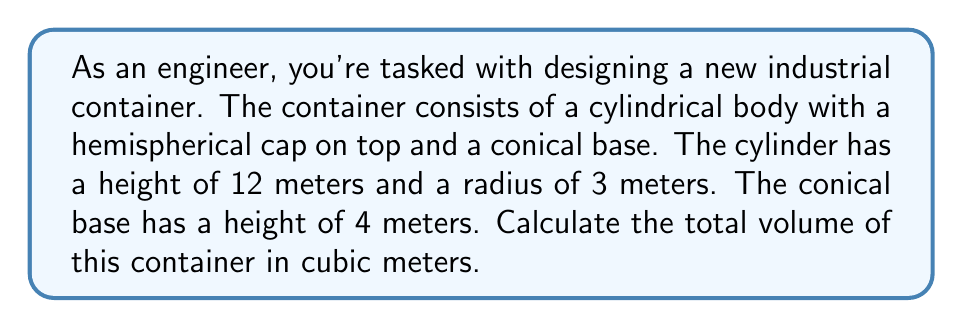Show me your answer to this math problem. Let's break this down step-by-step:

1. Calculate the volume of the cylindrical body:
   $$V_{cylinder} = \pi r^2 h$$
   $$V_{cylinder} = \pi \cdot 3^2 \cdot 12 = 108\pi \text{ m}^3$$

2. Calculate the volume of the hemispherical cap:
   $$V_{hemisphere} = \frac{2}{3}\pi r^3$$
   $$V_{hemisphere} = \frac{2}{3}\pi \cdot 3^3 = 18\pi \text{ m}^3$$

3. Calculate the volume of the conical base:
   $$V_{cone} = \frac{1}{3}\pi r^2 h$$
   $$V_{cone} = \frac{1}{3}\pi \cdot 3^2 \cdot 4 = 12\pi \text{ m}^3$$

4. Sum up all the volumes:
   $$V_{total} = V_{cylinder} + V_{hemisphere} + V_{cone}$$
   $$V_{total} = 108\pi + 18\pi + 12\pi = 138\pi \text{ m}^3$$

5. Simplify the final answer:
   $$V_{total} = 138\pi \approx 433.54 \text{ m}^3$$

[asy]
import three;

size(200);
currentprojection=perspective(6,3,2);

// Cylinder
draw(surface(cylinder((0,0,0),3,12)),lightgrey);

// Hemisphere
draw(surface(sphere((0,0,12),3)),lightgrey);

// Cone
draw(surface(cone((0,0,0),3,-4)),lightgrey);

// Labels
label("12m",(4,0,6),E);
label("3m",(0,-3.5,0),S);
label("4m",(-4,0,-2),W);
Answer: $433.54 \text{ m}^3$ 